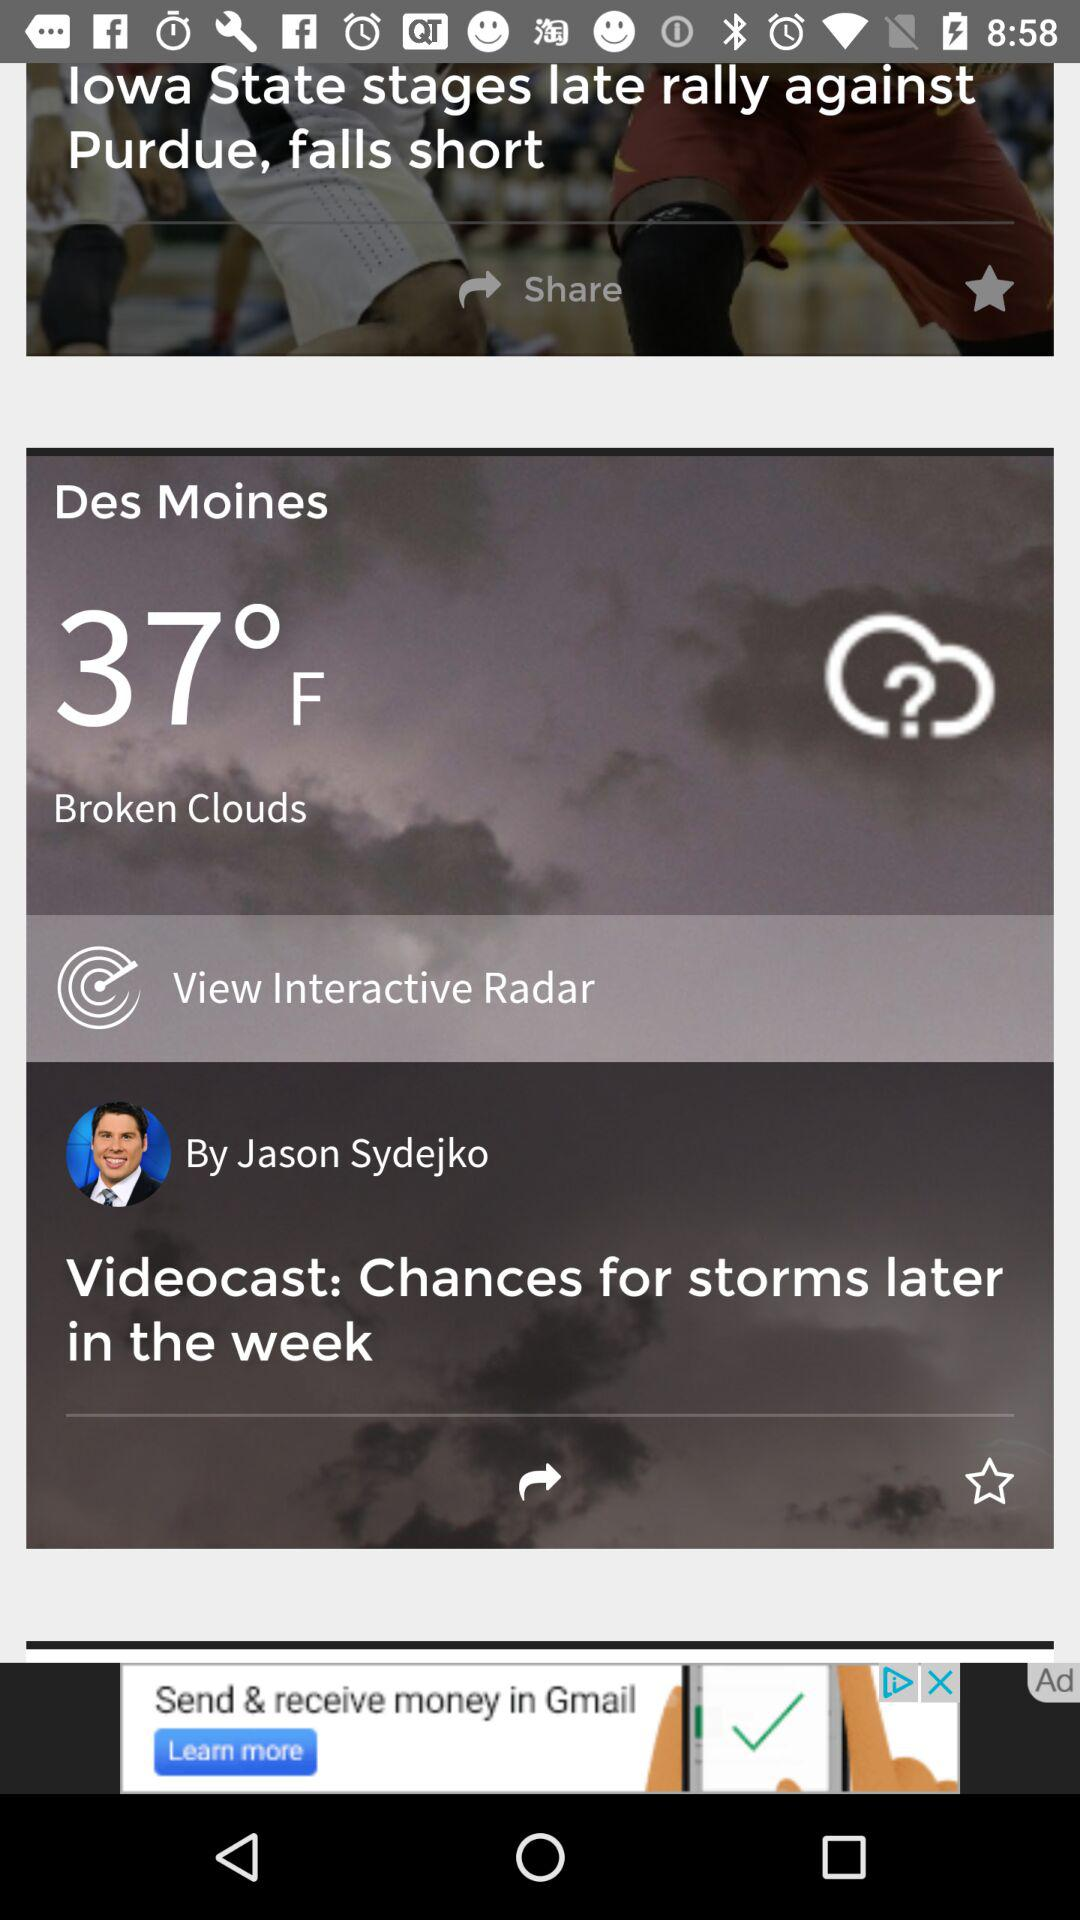How many degrees Fahrenheit is the temperature in Des Moines?
Answer the question using a single word or phrase. 37° F 